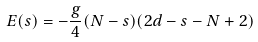Convert formula to latex. <formula><loc_0><loc_0><loc_500><loc_500>E ( s ) = - \frac { g } { 4 } ( N - s ) ( 2 d - s - N + 2 )</formula> 